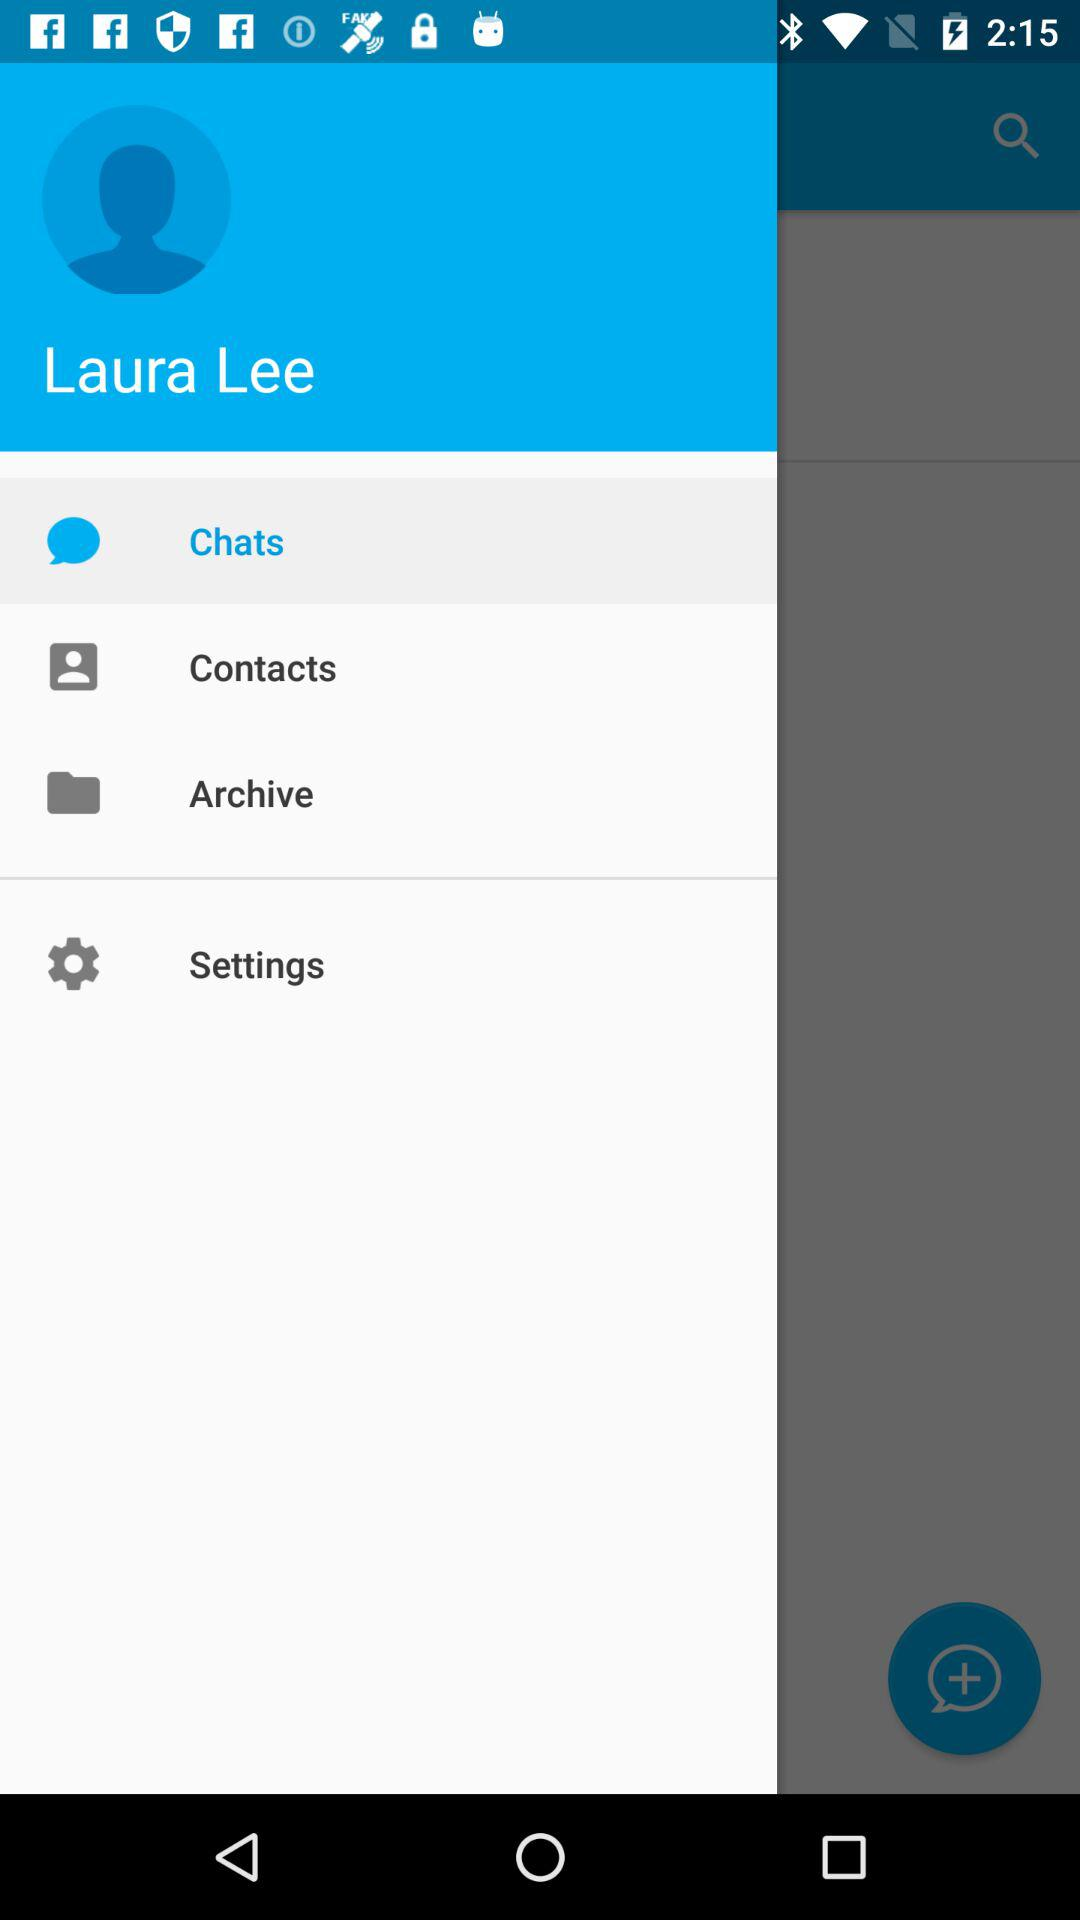What is the user name? The user name is Laura Lee. 